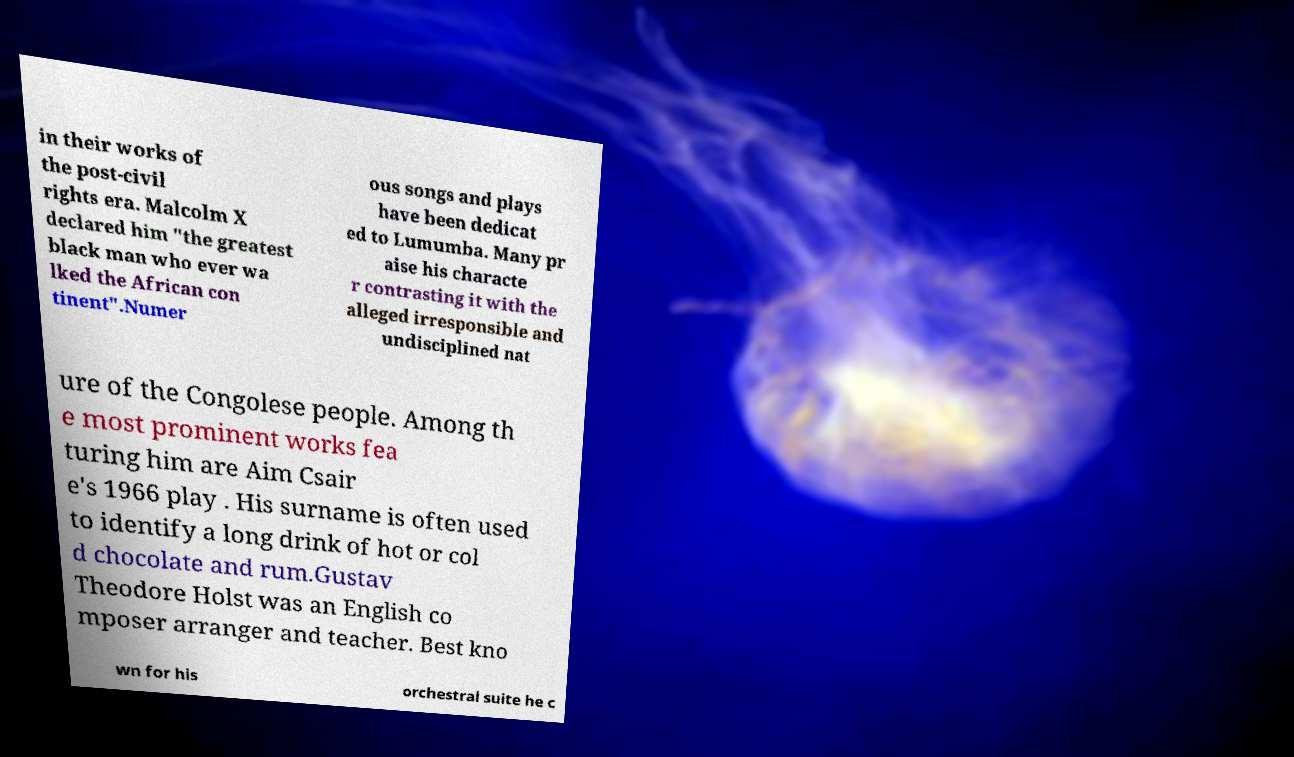Can you read and provide the text displayed in the image?This photo seems to have some interesting text. Can you extract and type it out for me? in their works of the post-civil rights era. Malcolm X declared him "the greatest black man who ever wa lked the African con tinent".Numer ous songs and plays have been dedicat ed to Lumumba. Many pr aise his characte r contrasting it with the alleged irresponsible and undisciplined nat ure of the Congolese people. Among th e most prominent works fea turing him are Aim Csair e's 1966 play . His surname is often used to identify a long drink of hot or col d chocolate and rum.Gustav Theodore Holst was an English co mposer arranger and teacher. Best kno wn for his orchestral suite he c 